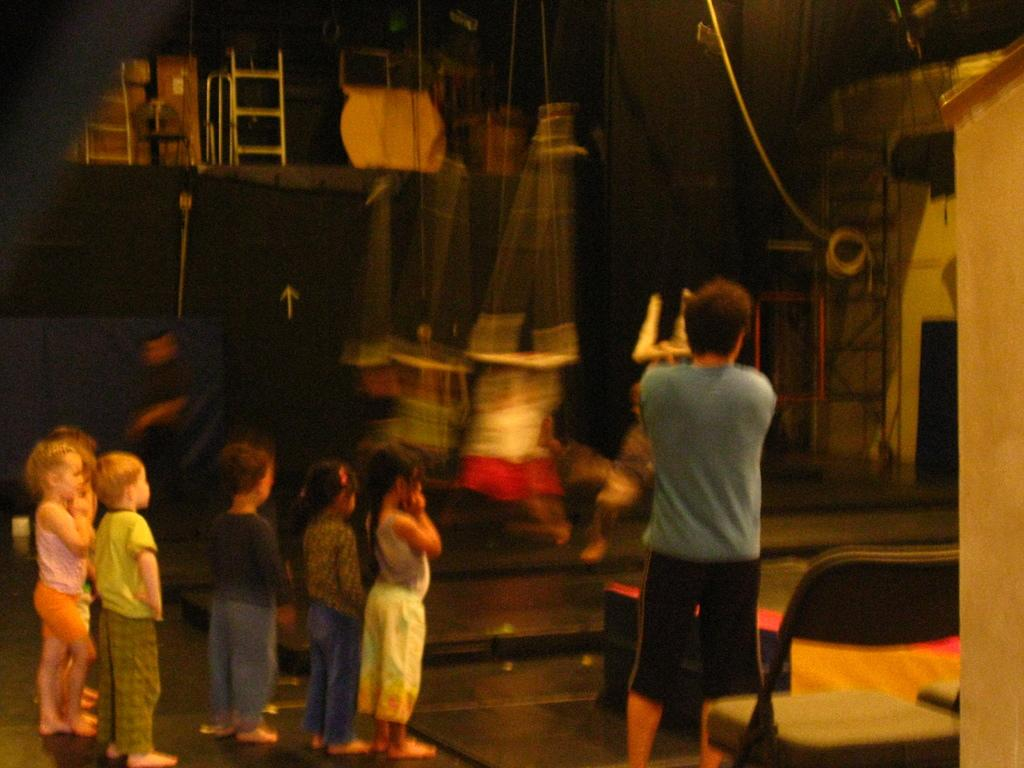Who is present in the image? There is a man and a group of children in the image. What are the children doing in the image? The children are standing on the floor, chairs, and ladders. What is the man doing in the image? The man is also standing on the floor. What can be seen in the background of the image? There are objects visible in the background of the image. What type of lip can be seen on the children's faces in the image? There is no lip visible on the children's faces in the image. What kind of pies are the children eating in the image? There are no pies present in the image; the children are standing on various surfaces. 